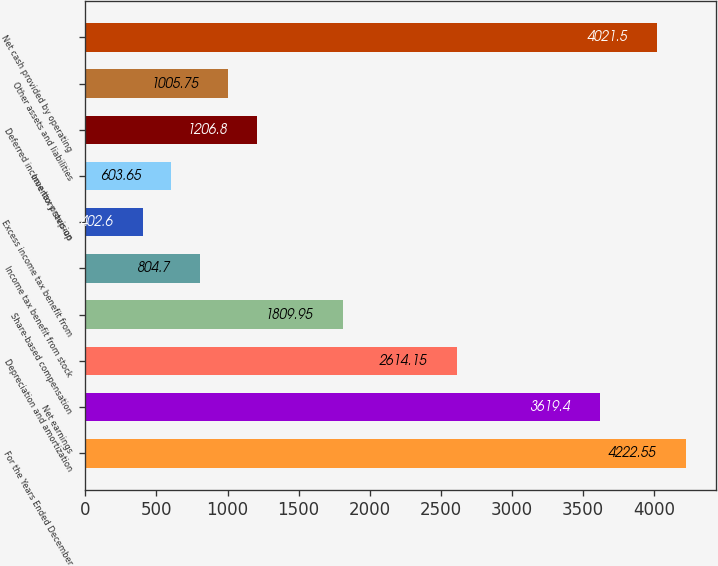Convert chart to OTSL. <chart><loc_0><loc_0><loc_500><loc_500><bar_chart><fcel>For the Years Ended December<fcel>Net earnings<fcel>Depreciation and amortization<fcel>Share-based compensation<fcel>Income tax benefit from stock<fcel>Excess income tax benefit from<fcel>Inventory step-up<fcel>Deferred income tax provision<fcel>Other assets and liabilities<fcel>Net cash provided by operating<nl><fcel>4222.55<fcel>3619.4<fcel>2614.15<fcel>1809.95<fcel>804.7<fcel>402.6<fcel>603.65<fcel>1206.8<fcel>1005.75<fcel>4021.5<nl></chart> 